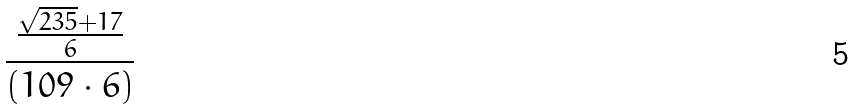<formula> <loc_0><loc_0><loc_500><loc_500>\frac { \frac { \sqrt { 2 3 5 } + 1 7 } { 6 } } { ( 1 0 9 \cdot 6 ) }</formula> 